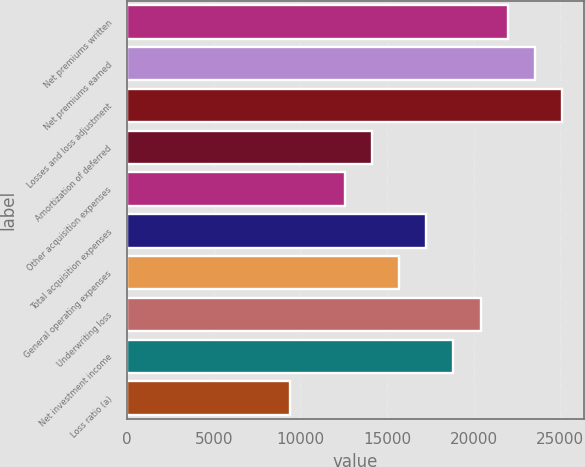<chart> <loc_0><loc_0><loc_500><loc_500><bar_chart><fcel>Net premiums written<fcel>Net premiums earned<fcel>Losses and loss adjustment<fcel>Amortization of deferred<fcel>Other acquisition expenses<fcel>Total acquisition expenses<fcel>General operating expenses<fcel>Underwriting loss<fcel>Net investment income<fcel>Loss ratio (a)<nl><fcel>21966.2<fcel>23534.7<fcel>25103.2<fcel>14123.5<fcel>12554.9<fcel>17260.5<fcel>15692<fcel>20397.6<fcel>18829.1<fcel>9417.84<nl></chart> 